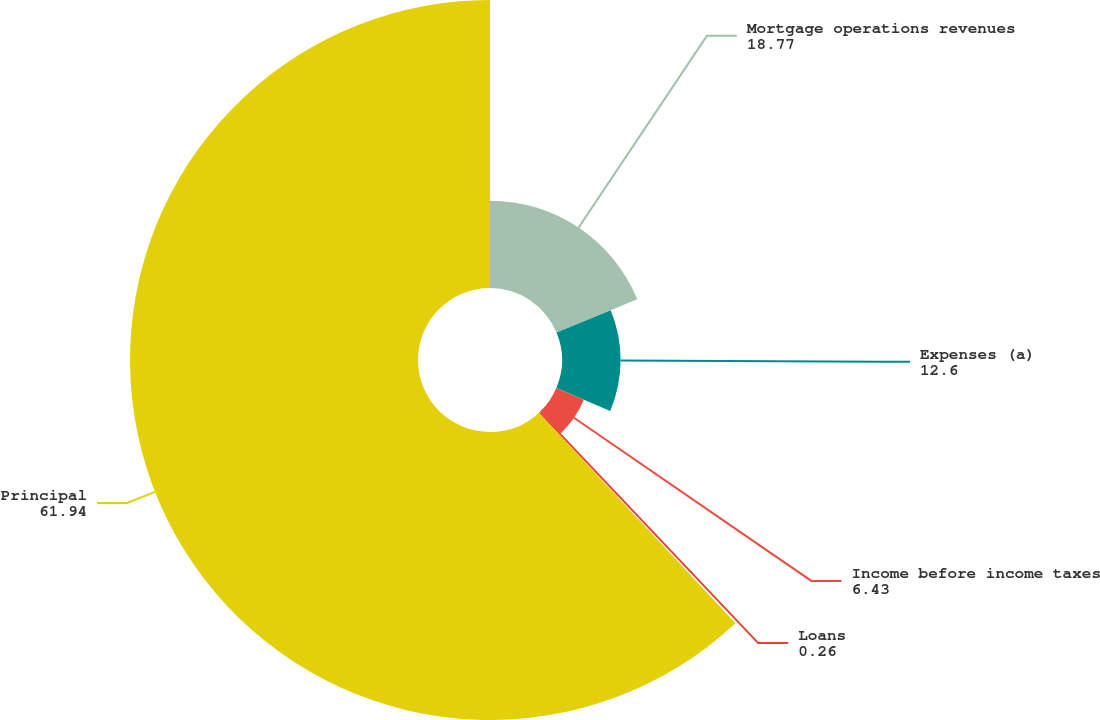Convert chart to OTSL. <chart><loc_0><loc_0><loc_500><loc_500><pie_chart><fcel>Mortgage operations revenues<fcel>Expenses (a)<fcel>Income before income taxes<fcel>Loans<fcel>Principal<nl><fcel>18.77%<fcel>12.6%<fcel>6.43%<fcel>0.26%<fcel>61.94%<nl></chart> 